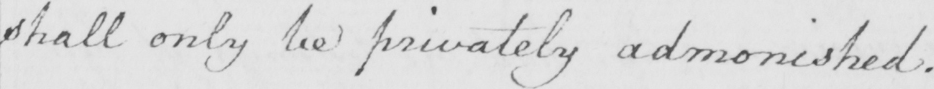What is written in this line of handwriting? shall only be privately admonished . 